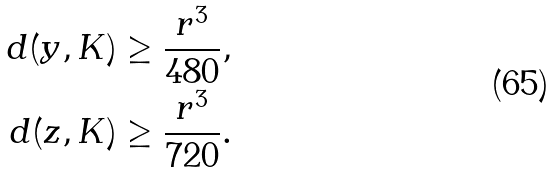Convert formula to latex. <formula><loc_0><loc_0><loc_500><loc_500>d ( y , K ) & \geq \frac { r ^ { 3 } } { 4 8 0 } , \\ d ( z , K ) & \geq \frac { r ^ { 3 } } { 7 2 0 } .</formula> 